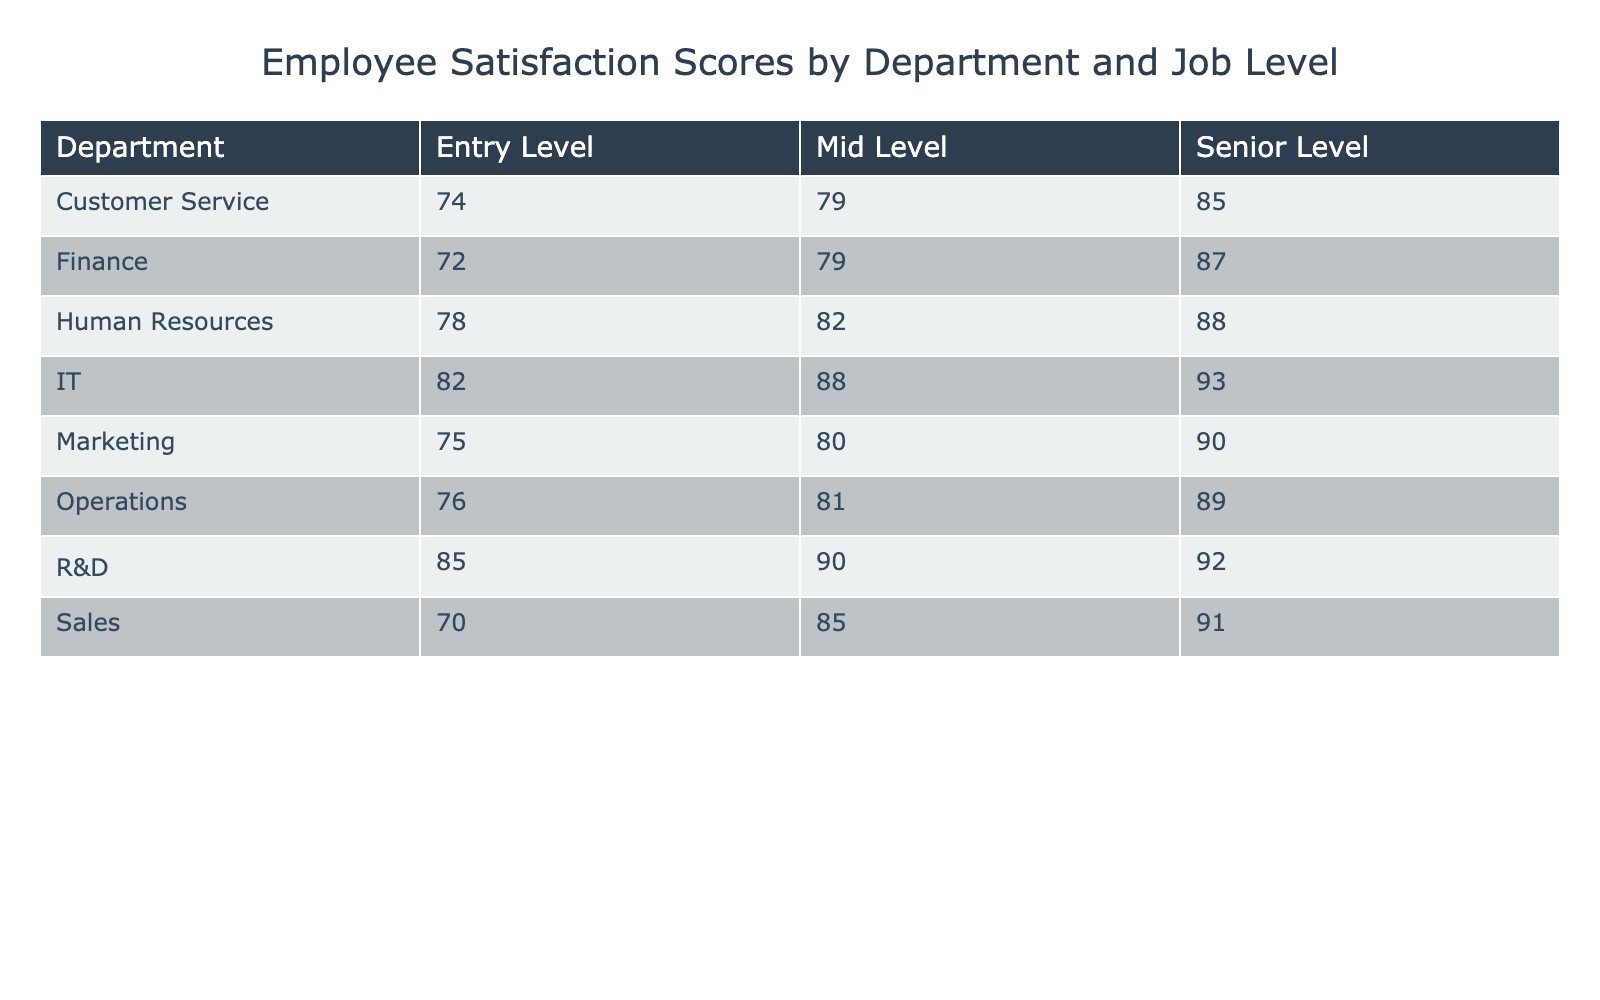What is the Employee Satisfaction Score for the Senior Level in the Marketing department? The table shows that the Employee Satisfaction Score for the Senior Level in the Marketing department is listed as 90.
Answer: 90 What is the average Employee Satisfaction Score for the Operations department? To calculate the average for the Operations department, add the scores together (76 + 81 + 89 = 246) and divide by the number of job levels (3). The average is 246/3 = 82.
Answer: 82 Is the Employee Satisfaction Score for the IT Senior Level higher than that of the Sales Senior Level? The Score for IT Senior Level is 93, and for Sales Senior Level is 91. Since 93 is greater than 91, the statement is true.
Answer: Yes Which department has the highest Employee Satisfaction Score at the Entry Level? Looking across all Entry Level scores, the highest score is from the R&D department, which is 85.
Answer: R&D What is the difference between the average Employee Satisfaction Score for Mid Level employees in Human Resources and Sales? First, calculate the average score for Mid Level in Human Resources (82) and Sales (85). The difference is 85 - 82 = 3.
Answer: 3 Does the Customer Service department have a higher average satisfaction score than Finance across all job levels? Calculate the averages: Customer Service (74 + 79 + 85 = 238, average is 79.3) and Finance (72 + 79 + 87 = 238, average is also 79.3). Since they are equal, the statement is false.
Answer: No What is the least satisfaction score in the Sales department? In the Sales department, the scores are 70, 85, and 91. The least score among these is 70.
Answer: 70 Which Job Level has the highest overall satisfaction score across all departments? Upon reviewing the highest scores for each job level, Senior Level has the highest score of 93 (IT department), while Entry Level has 85 (R&D department) and Mid Level has 90 (R&D department). Hence, Senior Level has the highest overall score.
Answer: Senior Level How many departments report an Employee Satisfaction Score greater than 85 at the Mid Level? By checking each department's Mid Level score, those above 85 are: Sales (85), IT (88), and R&D (90). That's 3 departments.
Answer: 3 